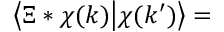<formula> <loc_0><loc_0><loc_500><loc_500>\Big \langle \Xi * \chi ( k ) \Big | \chi ( k ^ { \prime } ) \Big \rangle =</formula> 